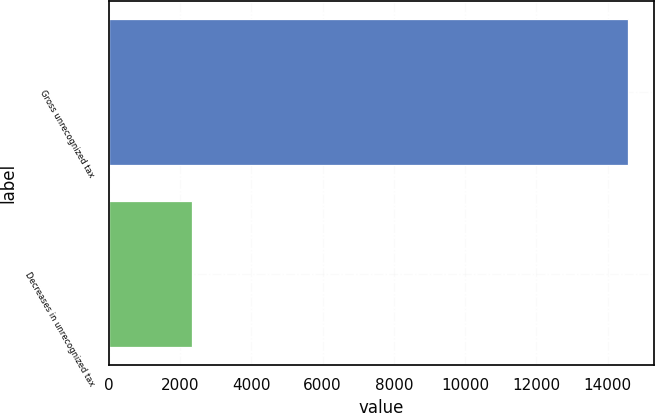Convert chart to OTSL. <chart><loc_0><loc_0><loc_500><loc_500><bar_chart><fcel>Gross unrecognized tax<fcel>Decreases in unrecognized tax<nl><fcel>14581<fcel>2341<nl></chart> 